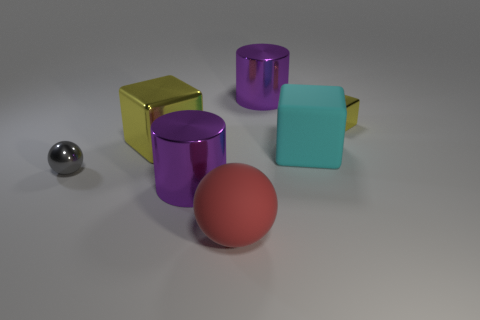Are there any particular textures or materials that stand out? Certainly, the materials of the objects vary, creating an interesting contrast in textures. The shiny surfaces of the silver sphere, yellow cube, and purple cylinders reflect light, giving them a glossy appearance that stands out against the matte textures of the red sphere and teal cube. The distinction between shiny and matte finishes adds depth to the scene and creates a visual dialogue between the objects' surfaces. 